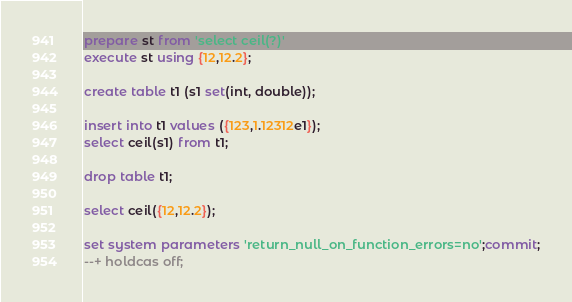Convert code to text. <code><loc_0><loc_0><loc_500><loc_500><_SQL_>
prepare st from 'select ceil(?)'
execute st using {12,12.2};

create table t1 (s1 set(int, double));

insert into t1 values ({123,1.12312e1});
select ceil(s1) from t1;

drop table t1;

select ceil({12,12.2});

set system parameters 'return_null_on_function_errors=no';commit;
--+ holdcas off;
</code> 